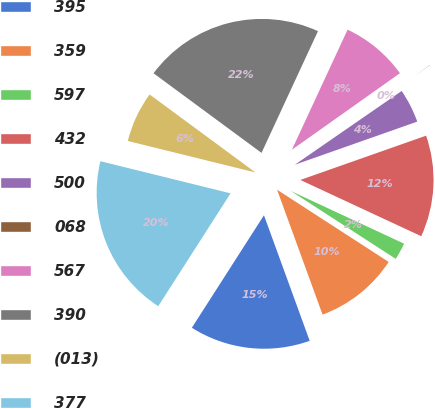Convert chart to OTSL. <chart><loc_0><loc_0><loc_500><loc_500><pie_chart><fcel>395<fcel>359<fcel>597<fcel>432<fcel>500<fcel>068<fcel>567<fcel>390<fcel>(013)<fcel>377<nl><fcel>14.63%<fcel>10.3%<fcel>2.21%<fcel>12.32%<fcel>4.23%<fcel>0.19%<fcel>8.28%<fcel>21.8%<fcel>6.26%<fcel>19.78%<nl></chart> 